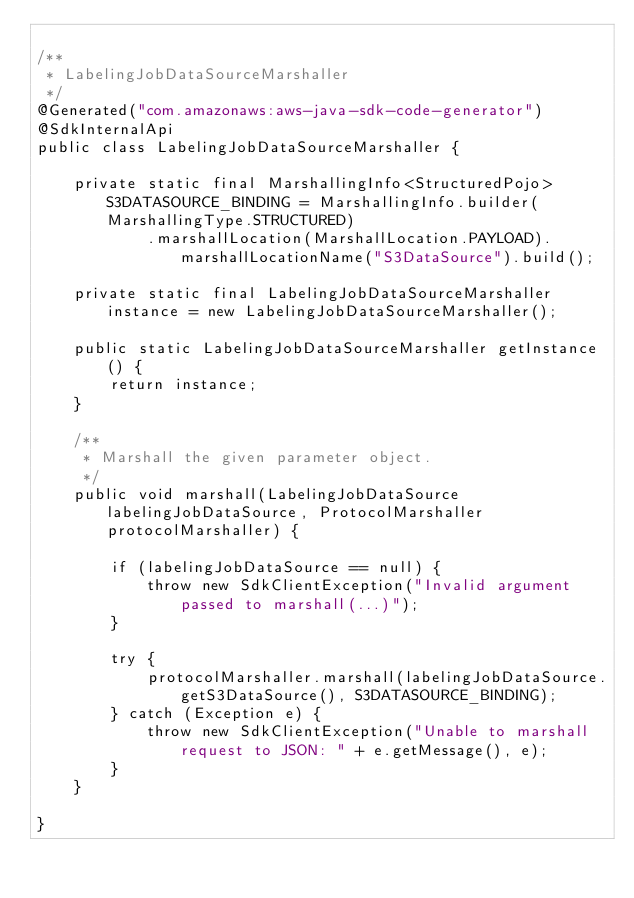Convert code to text. <code><loc_0><loc_0><loc_500><loc_500><_Java_>
/**
 * LabelingJobDataSourceMarshaller
 */
@Generated("com.amazonaws:aws-java-sdk-code-generator")
@SdkInternalApi
public class LabelingJobDataSourceMarshaller {

    private static final MarshallingInfo<StructuredPojo> S3DATASOURCE_BINDING = MarshallingInfo.builder(MarshallingType.STRUCTURED)
            .marshallLocation(MarshallLocation.PAYLOAD).marshallLocationName("S3DataSource").build();

    private static final LabelingJobDataSourceMarshaller instance = new LabelingJobDataSourceMarshaller();

    public static LabelingJobDataSourceMarshaller getInstance() {
        return instance;
    }

    /**
     * Marshall the given parameter object.
     */
    public void marshall(LabelingJobDataSource labelingJobDataSource, ProtocolMarshaller protocolMarshaller) {

        if (labelingJobDataSource == null) {
            throw new SdkClientException("Invalid argument passed to marshall(...)");
        }

        try {
            protocolMarshaller.marshall(labelingJobDataSource.getS3DataSource(), S3DATASOURCE_BINDING);
        } catch (Exception e) {
            throw new SdkClientException("Unable to marshall request to JSON: " + e.getMessage(), e);
        }
    }

}
</code> 